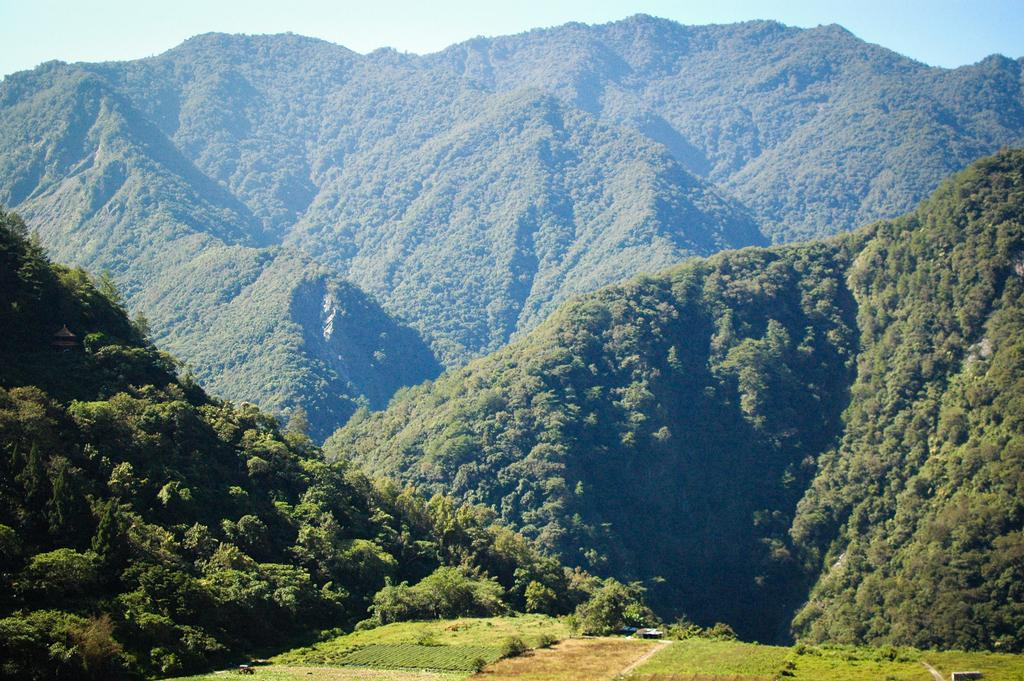What type of natural formation can be seen in the image? There are mountains in the image. What covers the mountains in the image? The mountains are covered with trees. What is visible at the top of the image? The sky is visible at the top of the image. What type of vegetation is visible at the bottom of the image? Grass is visible at the bottom of the image. How many clovers are growing on the trees in the image? There are no clovers visible in the image; the mountains are covered with trees. 